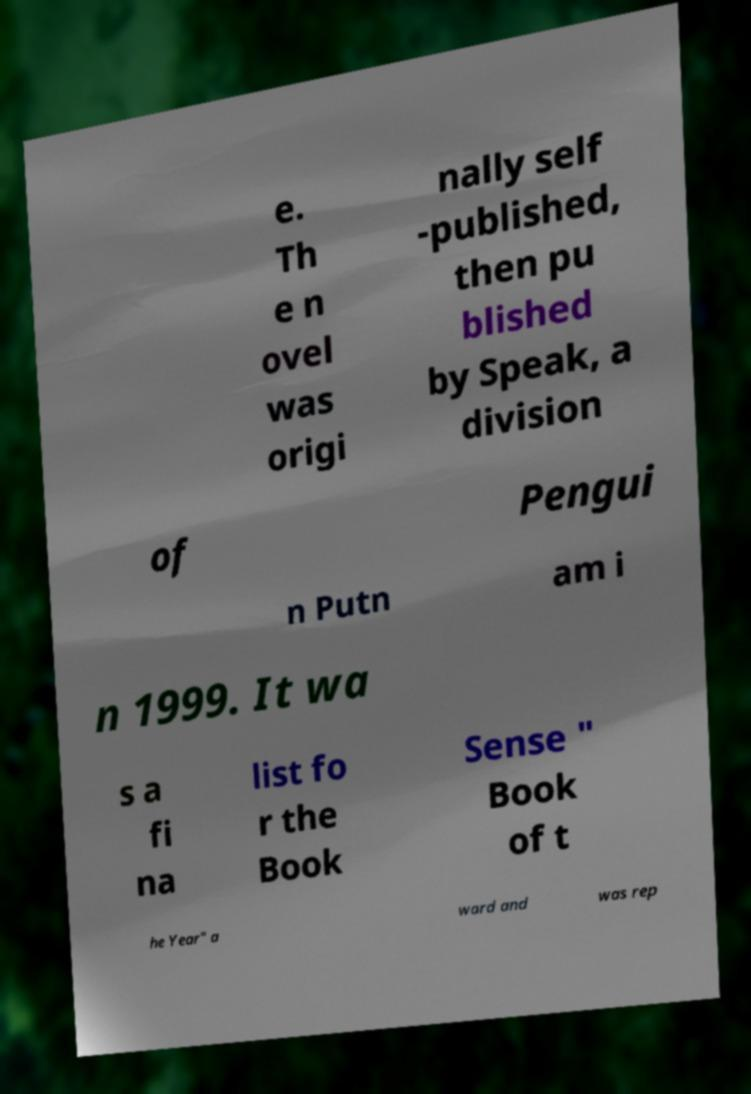For documentation purposes, I need the text within this image transcribed. Could you provide that? e. Th e n ovel was origi nally self -published, then pu blished by Speak, a division of Pengui n Putn am i n 1999. It wa s a fi na list fo r the Book Sense " Book of t he Year" a ward and was rep 